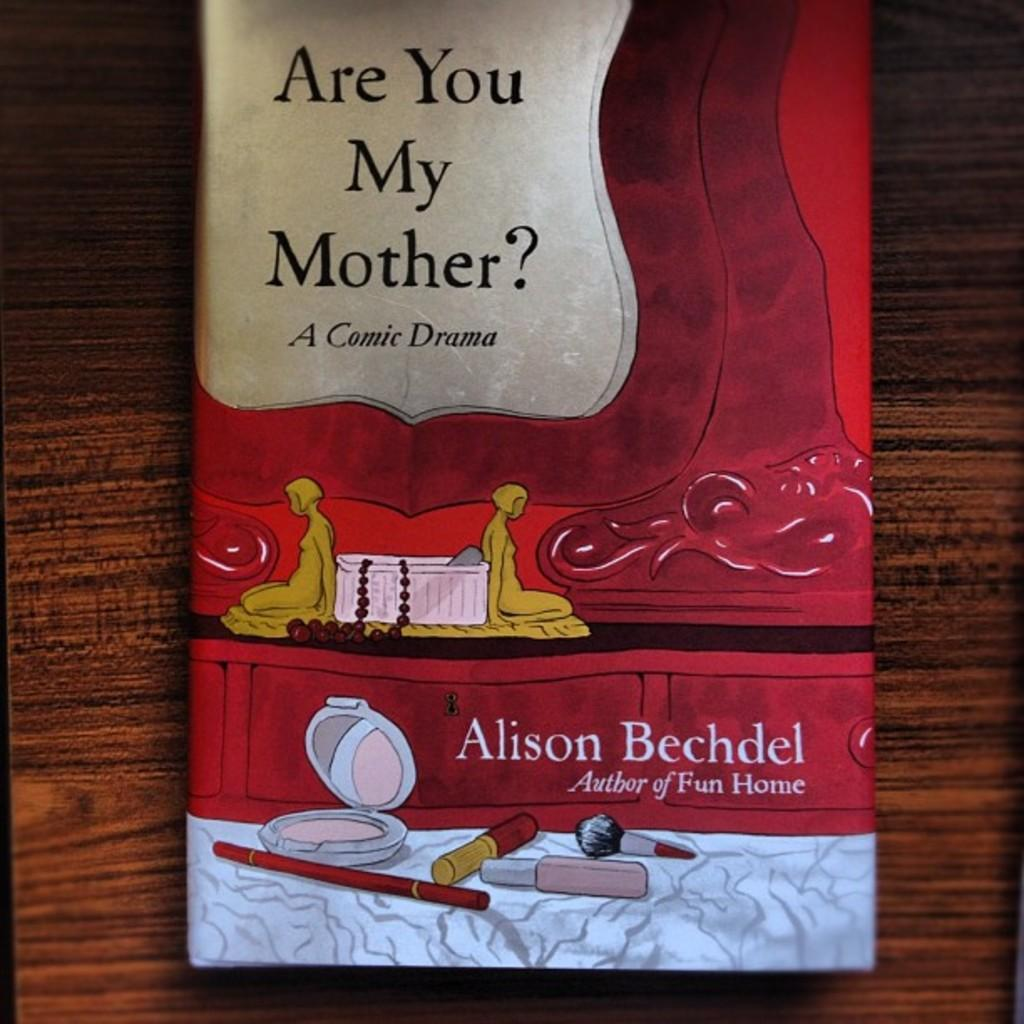<image>
Summarize the visual content of the image. a book by alison bechdel titled are you my mother? a comic drama 